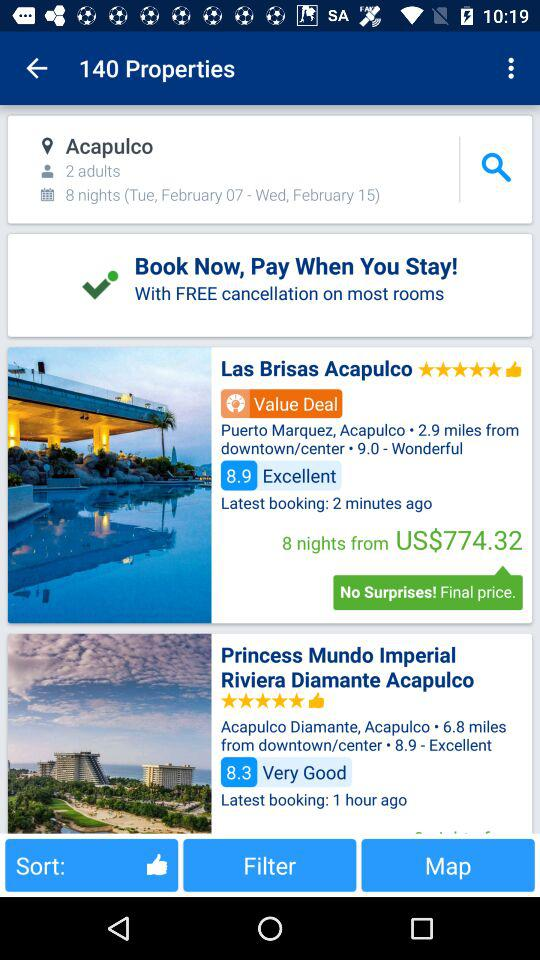When was the last booking done for "Las Brisas Acapulco"? The last booking was done 2 minutes ago. 